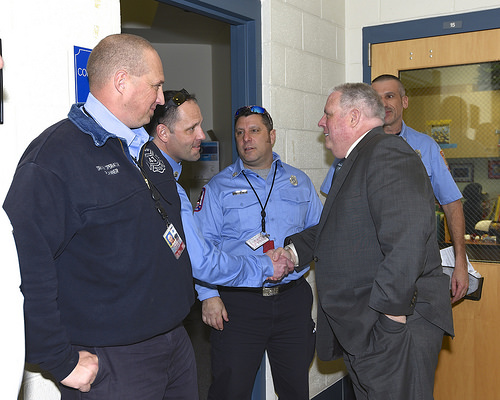<image>
Is there a building behind the man? Yes. From this viewpoint, the building is positioned behind the man, with the man partially or fully occluding the building. 